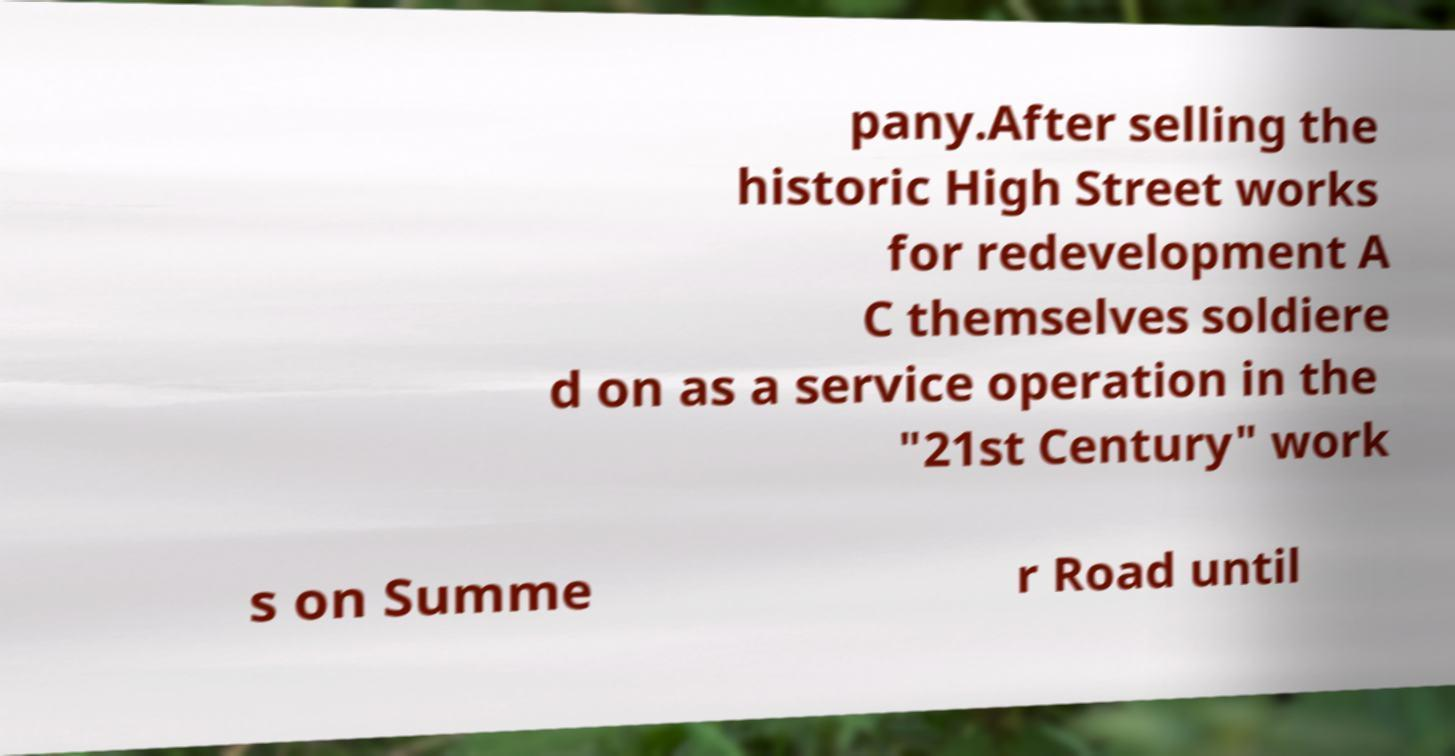Could you assist in decoding the text presented in this image and type it out clearly? pany.After selling the historic High Street works for redevelopment A C themselves soldiere d on as a service operation in the "21st Century" work s on Summe r Road until 